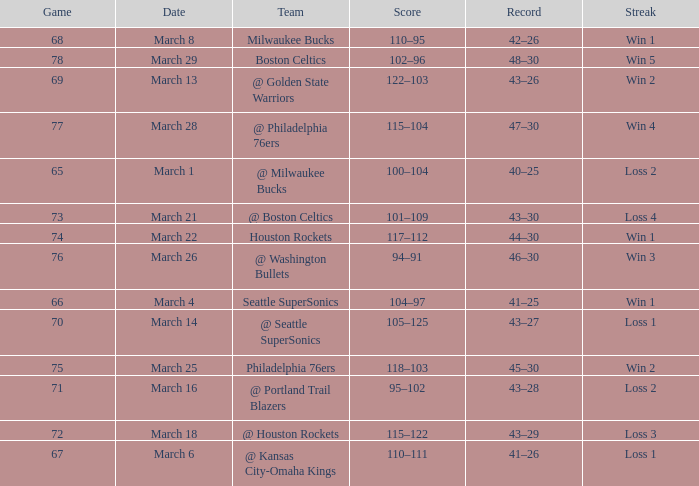What is Team, when Game is 73? @ Boston Celtics. 